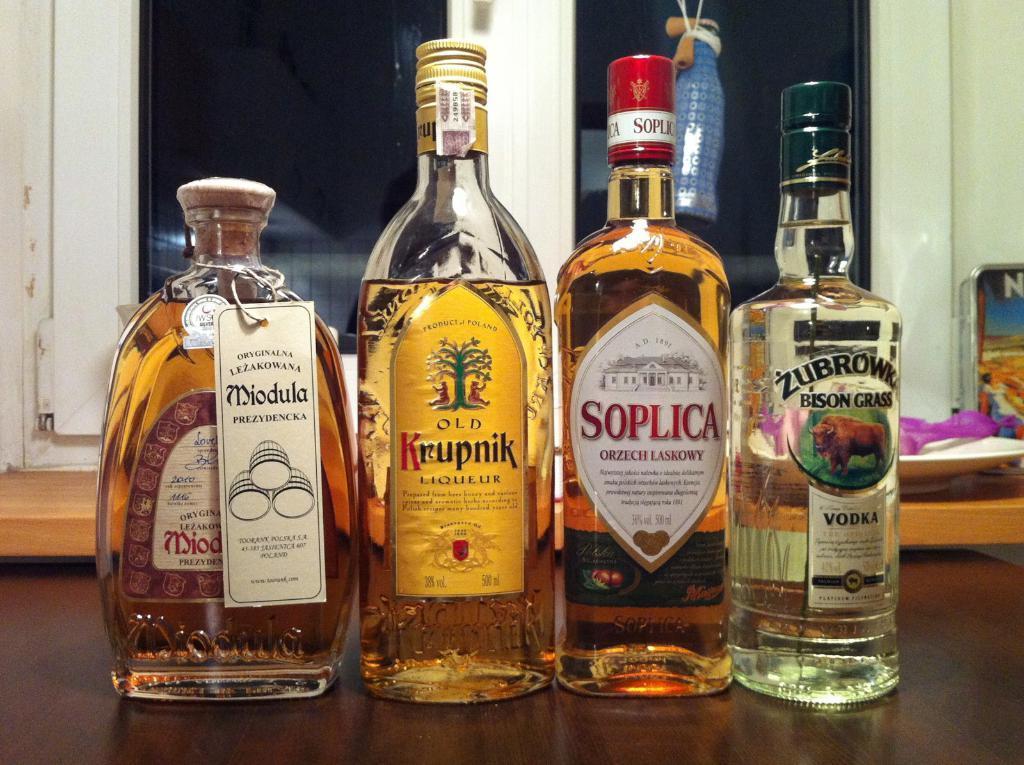Can you describe this image briefly? In this picture there are four alcohol bottles on the table. There are labels on the bottle and text on it. Behind the bottles there is a plate a spoon and a bottle hanging. In the background is wall and window. 